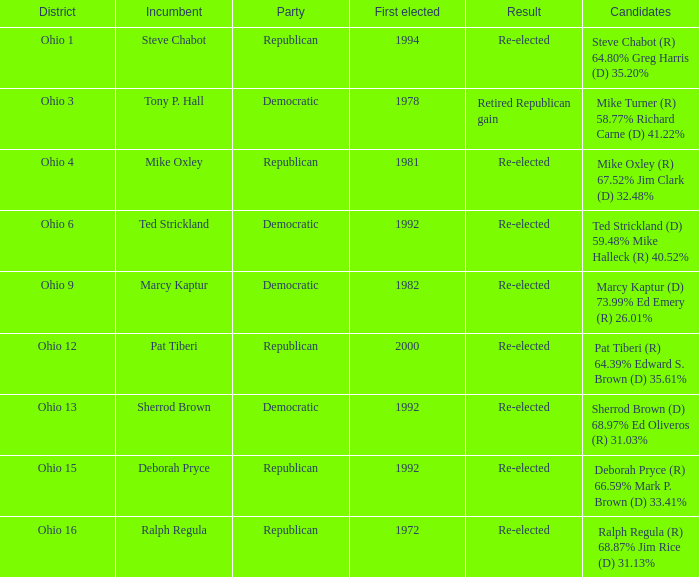In which area was the current steve chabot? Ohio 1. Can you parse all the data within this table? {'header': ['District', 'Incumbent', 'Party', 'First elected', 'Result', 'Candidates'], 'rows': [['Ohio 1', 'Steve Chabot', 'Republican', '1994', 'Re-elected', 'Steve Chabot (R) 64.80% Greg Harris (D) 35.20%'], ['Ohio 3', 'Tony P. Hall', 'Democratic', '1978', 'Retired Republican gain', 'Mike Turner (R) 58.77% Richard Carne (D) 41.22%'], ['Ohio 4', 'Mike Oxley', 'Republican', '1981', 'Re-elected', 'Mike Oxley (R) 67.52% Jim Clark (D) 32.48%'], ['Ohio 6', 'Ted Strickland', 'Democratic', '1992', 'Re-elected', 'Ted Strickland (D) 59.48% Mike Halleck (R) 40.52%'], ['Ohio 9', 'Marcy Kaptur', 'Democratic', '1982', 'Re-elected', 'Marcy Kaptur (D) 73.99% Ed Emery (R) 26.01%'], ['Ohio 12', 'Pat Tiberi', 'Republican', '2000', 'Re-elected', 'Pat Tiberi (R) 64.39% Edward S. Brown (D) 35.61%'], ['Ohio 13', 'Sherrod Brown', 'Democratic', '1992', 'Re-elected', 'Sherrod Brown (D) 68.97% Ed Oliveros (R) 31.03%'], ['Ohio 15', 'Deborah Pryce', 'Republican', '1992', 'Re-elected', 'Deborah Pryce (R) 66.59% Mark P. Brown (D) 33.41%'], ['Ohio 16', 'Ralph Regula', 'Republican', '1972', 'Re-elected', 'Ralph Regula (R) 68.87% Jim Rice (D) 31.13%']]} 